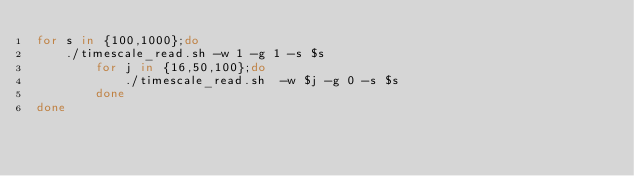<code> <loc_0><loc_0><loc_500><loc_500><_Bash_>for s in {100,1000};do
		./timescale_read.sh -w 1 -g 1 -s $s
        for j in {16,50,100};do
            ./timescale_read.sh  -w $j -g 0 -s $s
        done
done
</code> 